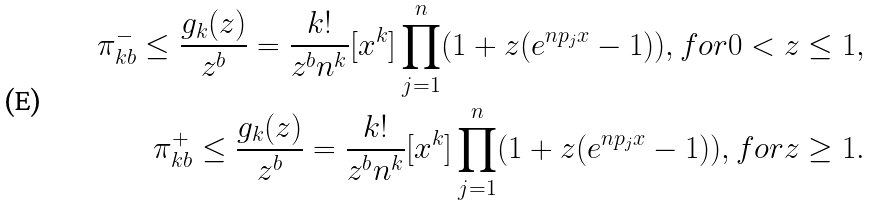<formula> <loc_0><loc_0><loc_500><loc_500>\pi _ { k b } ^ { - } \leq \frac { g _ { k } ( z ) } { z ^ { b } } = \frac { k ! } { z ^ { b } n ^ { k } } [ x ^ { k } ] \prod _ { j = 1 } ^ { n } ( 1 + z ( e ^ { n p _ { j } x } - 1 ) ) , f o r 0 < z \leq 1 , \\ \pi _ { k b } ^ { + } \leq \frac { g _ { k } ( z ) } { z ^ { b } } = \frac { k ! } { z ^ { b } n ^ { k } } [ x ^ { k } ] \prod _ { j = 1 } ^ { n } ( 1 + z ( e ^ { n p _ { j } x } - 1 ) ) , f o r z \geq 1 .</formula> 